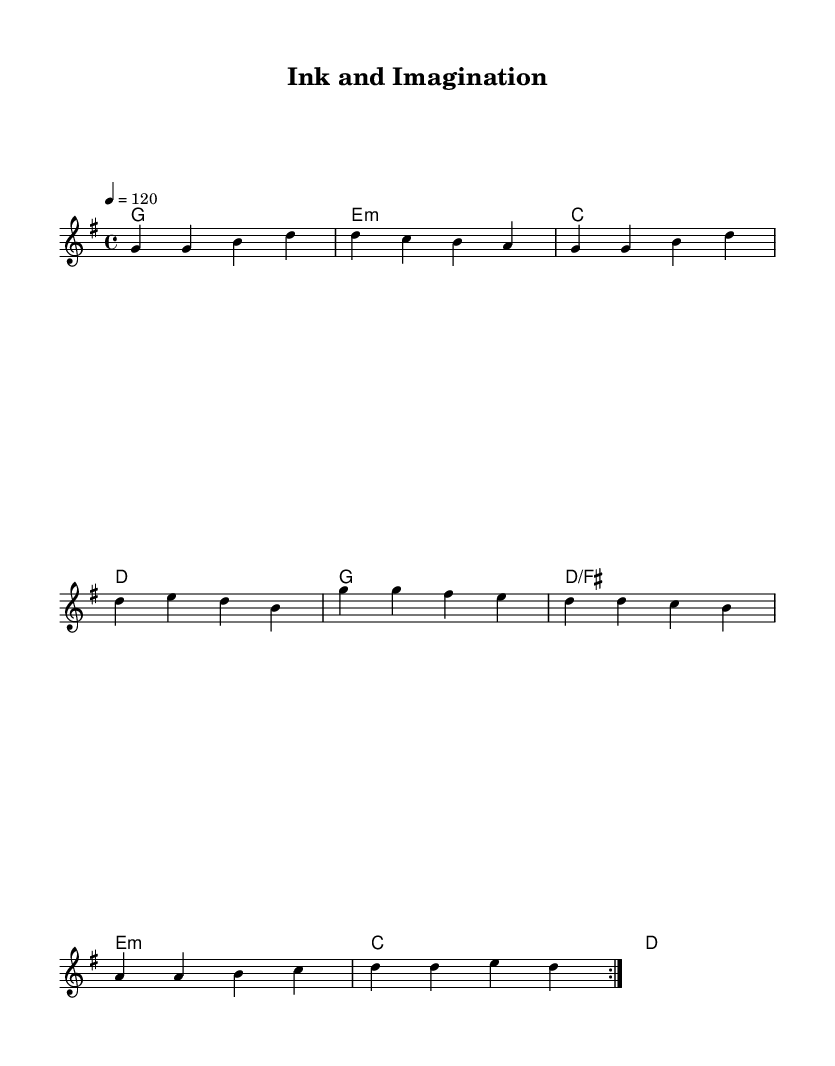What is the key signature of this music? The key signature is G major, which has one sharp (F#). This can be identified by looking at the key signature at the beginning of the sheet music.
Answer: G major What is the time signature of this music? The time signature is 4/4, which means there are four beats in each measure and the quarter note receives one beat. This is indicated in the sheet music right after the clef at the beginning.
Answer: 4/4 What is the tempo marking of this music? The tempo marking is 120 beats per minute, indicated by the instruction "4 = 120" at the start of the music. This tells us the speed at which the piece should be played.
Answer: 120 How many measures are repeated in the melody section? There are two measures repeated in the melody, as indicated by the use of the "repeat volta 2" notation at the beginning of that section. This clearly states that the melody should be played twice.
Answer: 2 What is the first chord in the harmony section? The first chord in the harmony section is G major, which is denoted as "g1" in the sheet music. This is shown at the beginning of the harmonies line.
Answer: G major Which chord follows the E minor chord in the harmony section? The chord that follows the E minor chord is C major. This can be determined by examining the sequence of chords listed after the E minor in the harmony line.
Answer: C major 